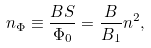<formula> <loc_0><loc_0><loc_500><loc_500>n _ { \Phi } \equiv \frac { B S } { \Phi _ { 0 } } = \frac { B } { B _ { 1 } } n ^ { 2 } ,</formula> 